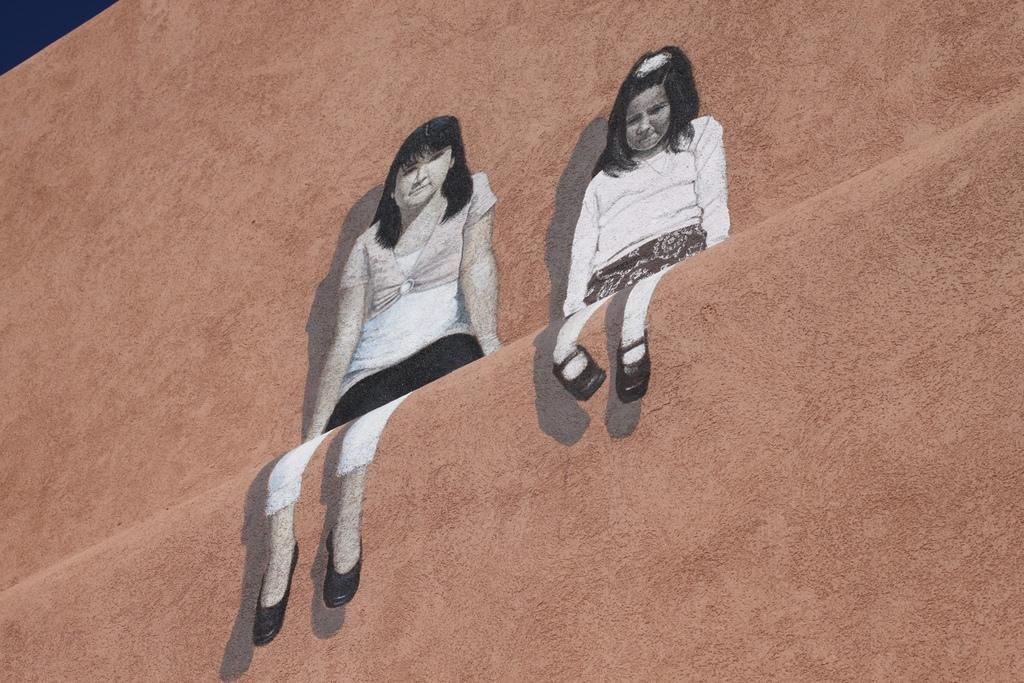What is depicted on the wall in the image? There is an art piece of two girls on the wall. What color is the wall in the background? The wall in the background is brown. Can you tell me how many receipts are on the floor in the image? There are no receipts present in the image. Is there any snow visible in the image? There is no snow present in the image. 